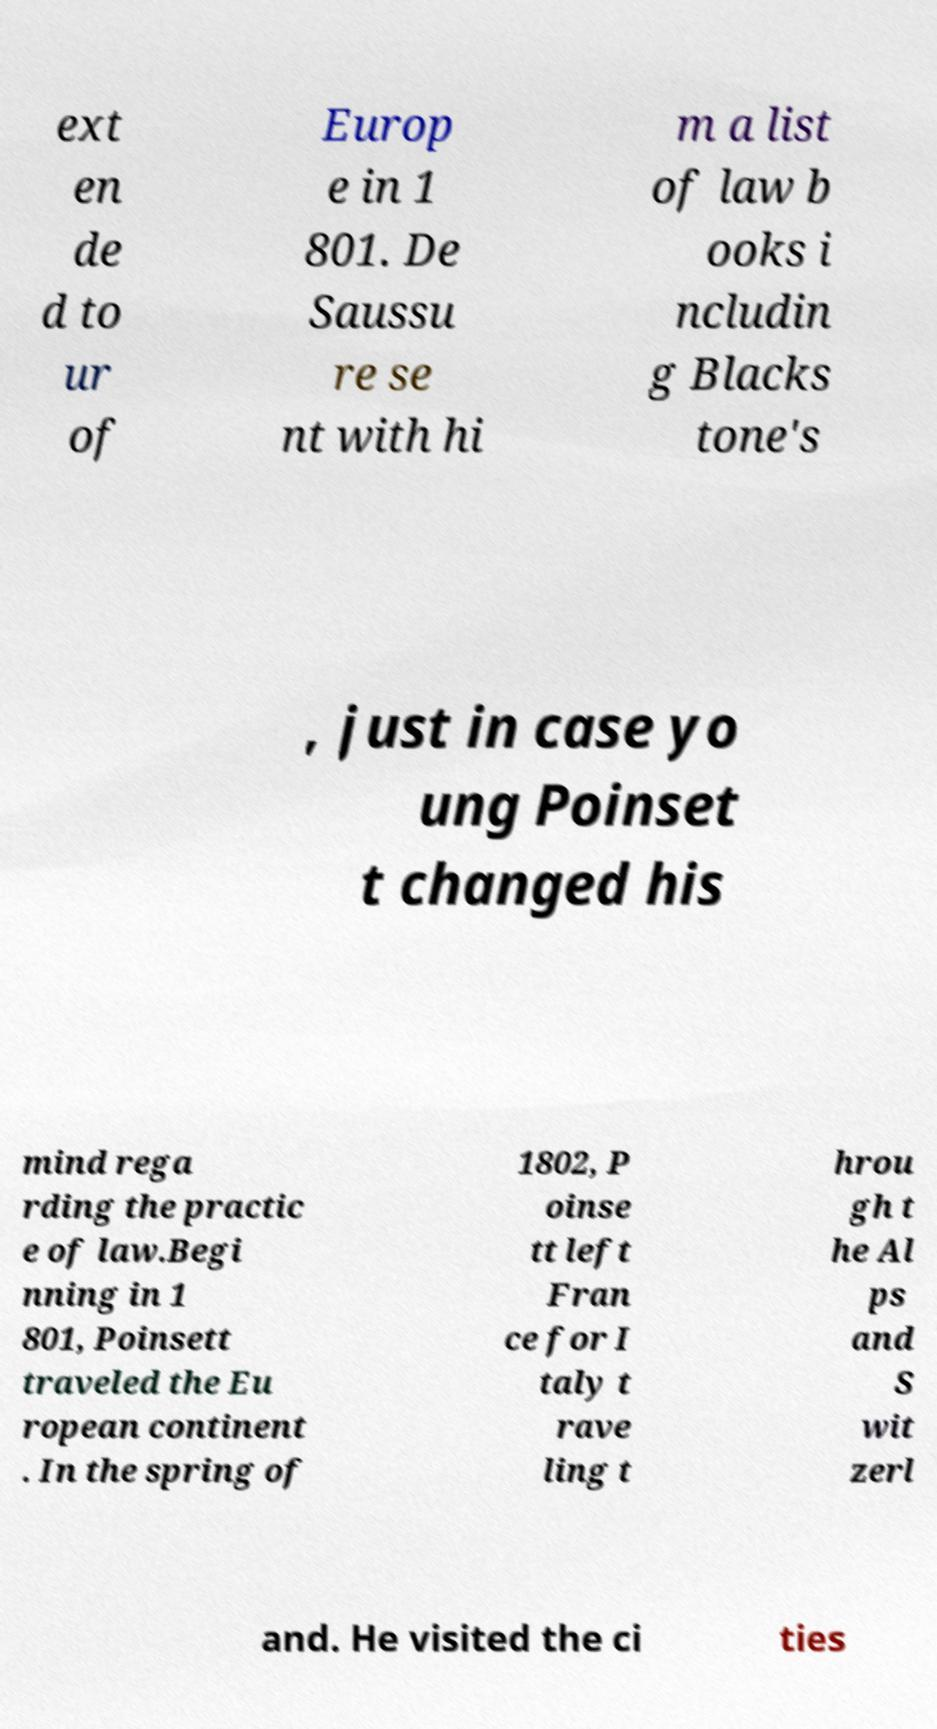I need the written content from this picture converted into text. Can you do that? ext en de d to ur of Europ e in 1 801. De Saussu re se nt with hi m a list of law b ooks i ncludin g Blacks tone's , just in case yo ung Poinset t changed his mind rega rding the practic e of law.Begi nning in 1 801, Poinsett traveled the Eu ropean continent . In the spring of 1802, P oinse tt left Fran ce for I taly t rave ling t hrou gh t he Al ps and S wit zerl and. He visited the ci ties 